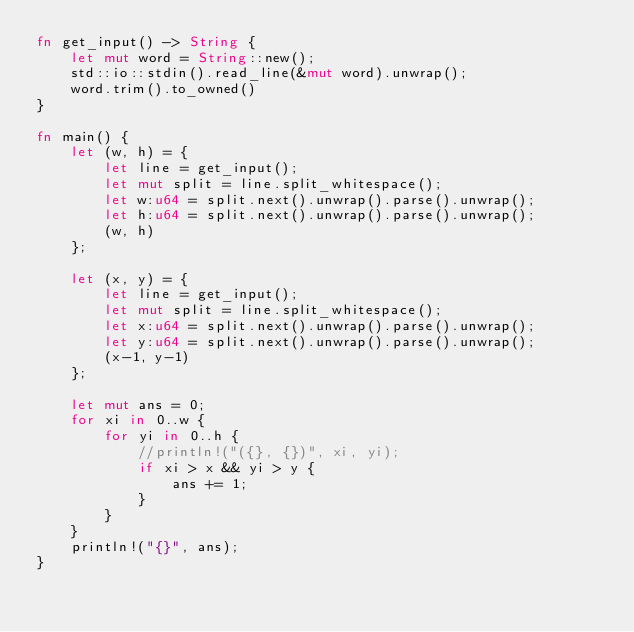<code> <loc_0><loc_0><loc_500><loc_500><_Rust_>fn get_input() -> String {
    let mut word = String::new();
    std::io::stdin().read_line(&mut word).unwrap();
    word.trim().to_owned()
}

fn main() {
	let (w, h) = {
    	let line = get_input();
    	let mut split = line.split_whitespace();
    	let w:u64 = split.next().unwrap().parse().unwrap();
    	let h:u64 = split.next().unwrap().parse().unwrap();
        (w, h)
    };
    
    let (x, y) = {
    	let line = get_input();
    	let mut split = line.split_whitespace();
    	let x:u64 = split.next().unwrap().parse().unwrap();
    	let y:u64 = split.next().unwrap().parse().unwrap();
        (x-1, y-1)
    };
    
    let mut ans = 0;
    for xi in 0..w {
    	for yi in 0..h {
        	//println!("({}, {})", xi, yi);
        	if xi > x && yi > y {
            	ans += 1;
            }
        }
    }
    println!("{}", ans);
}</code> 